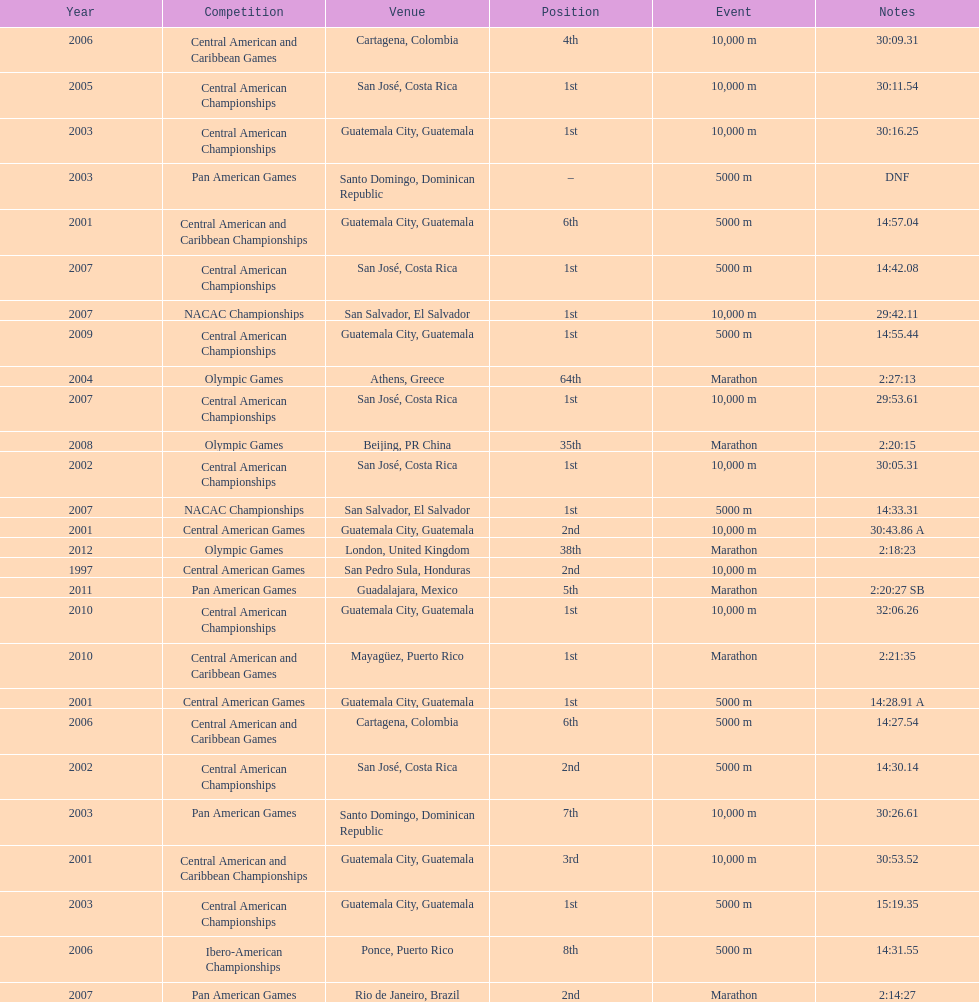Which event is listed more between the 10,000m and the 5000m? 10,000 m. 